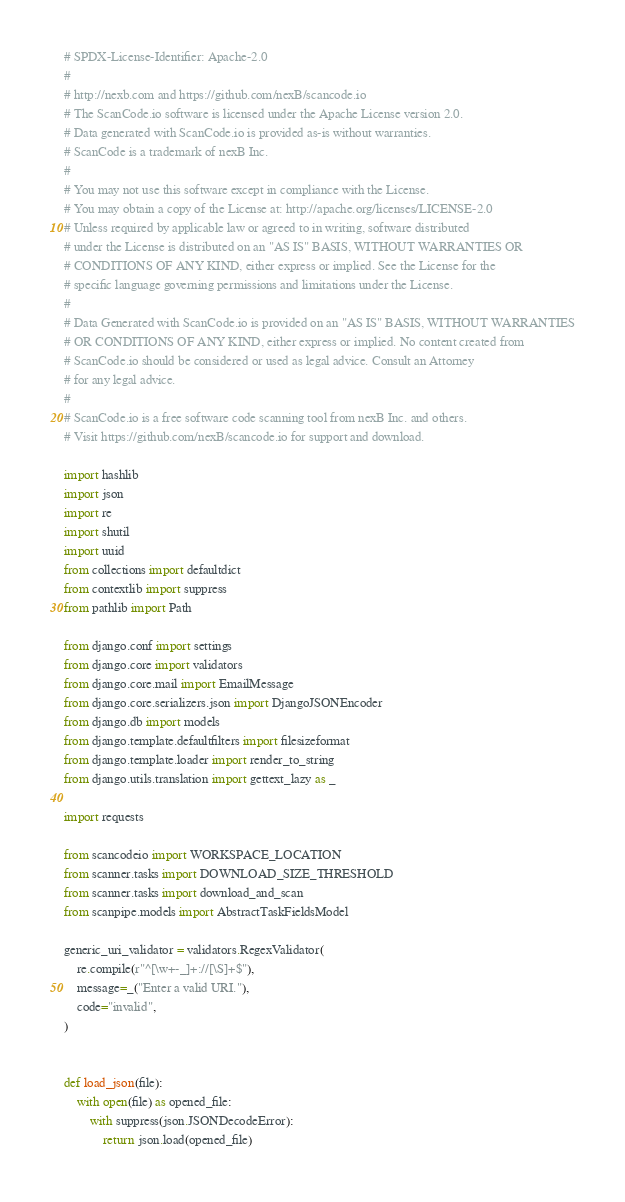<code> <loc_0><loc_0><loc_500><loc_500><_Python_># SPDX-License-Identifier: Apache-2.0
#
# http://nexb.com and https://github.com/nexB/scancode.io
# The ScanCode.io software is licensed under the Apache License version 2.0.
# Data generated with ScanCode.io is provided as-is without warranties.
# ScanCode is a trademark of nexB Inc.
#
# You may not use this software except in compliance with the License.
# You may obtain a copy of the License at: http://apache.org/licenses/LICENSE-2.0
# Unless required by applicable law or agreed to in writing, software distributed
# under the License is distributed on an "AS IS" BASIS, WITHOUT WARRANTIES OR
# CONDITIONS OF ANY KIND, either express or implied. See the License for the
# specific language governing permissions and limitations under the License.
#
# Data Generated with ScanCode.io is provided on an "AS IS" BASIS, WITHOUT WARRANTIES
# OR CONDITIONS OF ANY KIND, either express or implied. No content created from
# ScanCode.io should be considered or used as legal advice. Consult an Attorney
# for any legal advice.
#
# ScanCode.io is a free software code scanning tool from nexB Inc. and others.
# Visit https://github.com/nexB/scancode.io for support and download.

import hashlib
import json
import re
import shutil
import uuid
from collections import defaultdict
from contextlib import suppress
from pathlib import Path

from django.conf import settings
from django.core import validators
from django.core.mail import EmailMessage
from django.core.serializers.json import DjangoJSONEncoder
from django.db import models
from django.template.defaultfilters import filesizeformat
from django.template.loader import render_to_string
from django.utils.translation import gettext_lazy as _

import requests

from scancodeio import WORKSPACE_LOCATION
from scanner.tasks import DOWNLOAD_SIZE_THRESHOLD
from scanner.tasks import download_and_scan
from scanpipe.models import AbstractTaskFieldsModel

generic_uri_validator = validators.RegexValidator(
    re.compile(r"^[\w+-_]+://[\S]+$"),
    message=_("Enter a valid URI."),
    code="invalid",
)


def load_json(file):
    with open(file) as opened_file:
        with suppress(json.JSONDecodeError):
            return json.load(opened_file)

</code> 